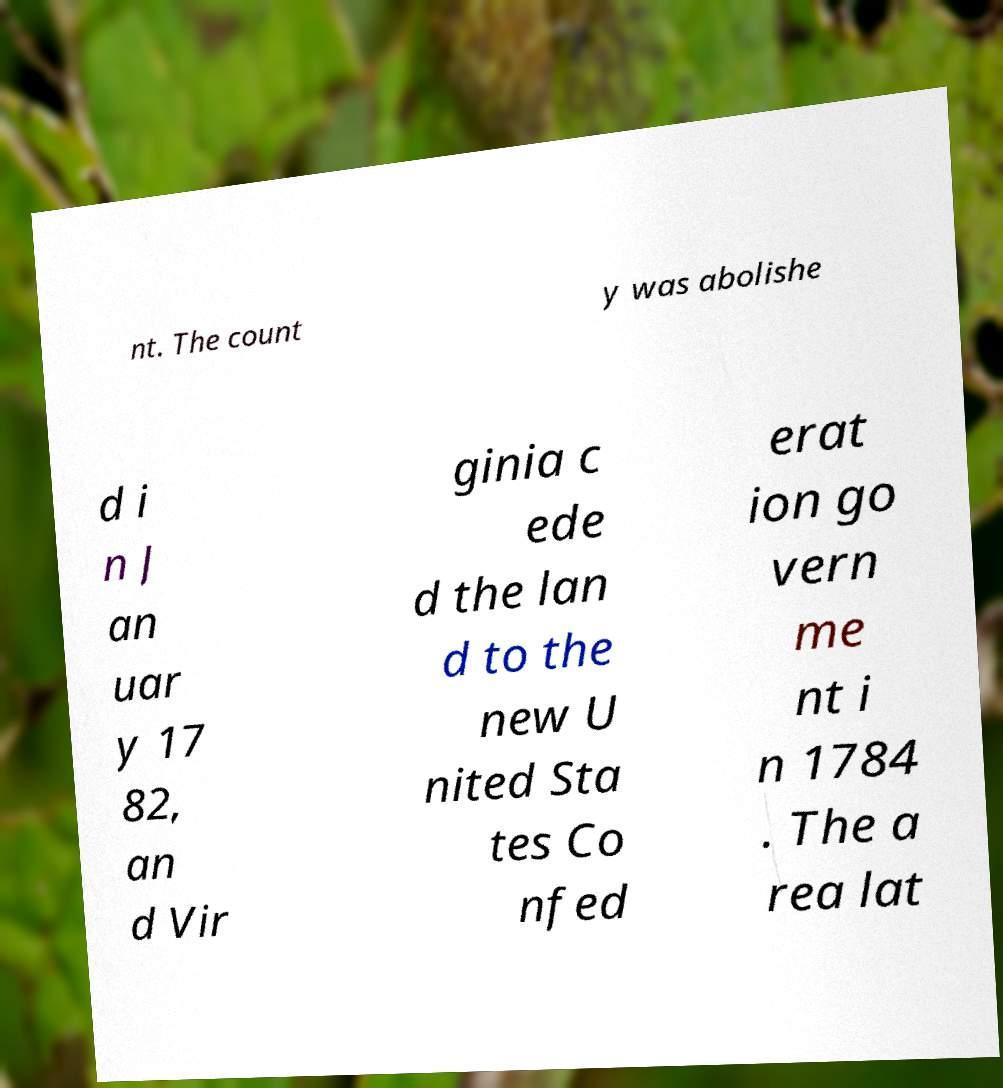Can you accurately transcribe the text from the provided image for me? nt. The count y was abolishe d i n J an uar y 17 82, an d Vir ginia c ede d the lan d to the new U nited Sta tes Co nfed erat ion go vern me nt i n 1784 . The a rea lat 